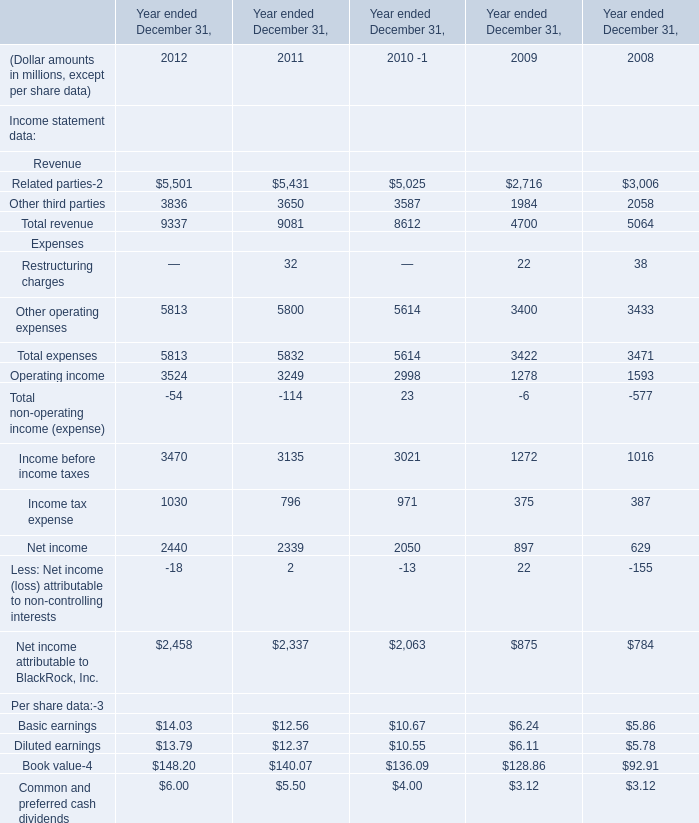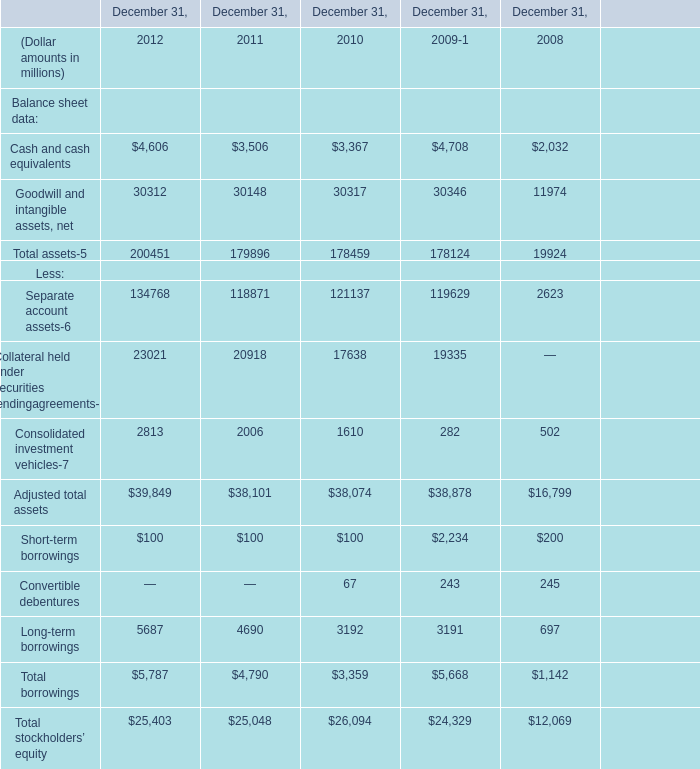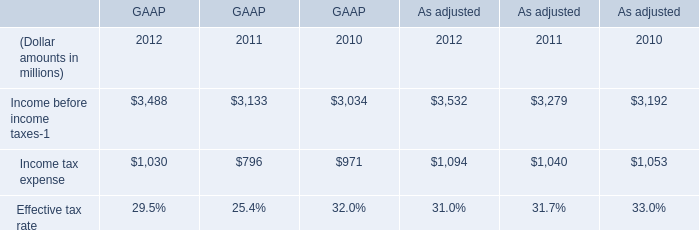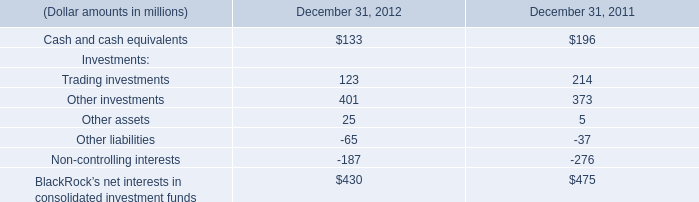what is the growth rate in sublease revenues from 2007 to 2008? 
Computations: ((7.1 - 7.7) / 7.7)
Answer: -0.07792. 